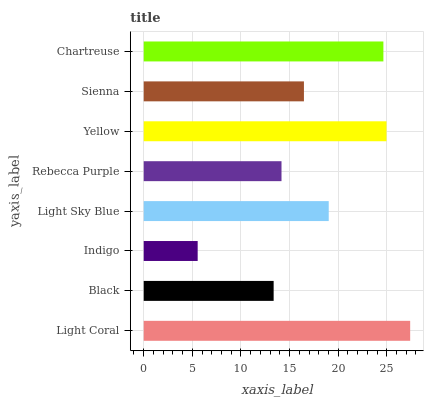Is Indigo the minimum?
Answer yes or no. Yes. Is Light Coral the maximum?
Answer yes or no. Yes. Is Black the minimum?
Answer yes or no. No. Is Black the maximum?
Answer yes or no. No. Is Light Coral greater than Black?
Answer yes or no. Yes. Is Black less than Light Coral?
Answer yes or no. Yes. Is Black greater than Light Coral?
Answer yes or no. No. Is Light Coral less than Black?
Answer yes or no. No. Is Light Sky Blue the high median?
Answer yes or no. Yes. Is Sienna the low median?
Answer yes or no. Yes. Is Yellow the high median?
Answer yes or no. No. Is Indigo the low median?
Answer yes or no. No. 